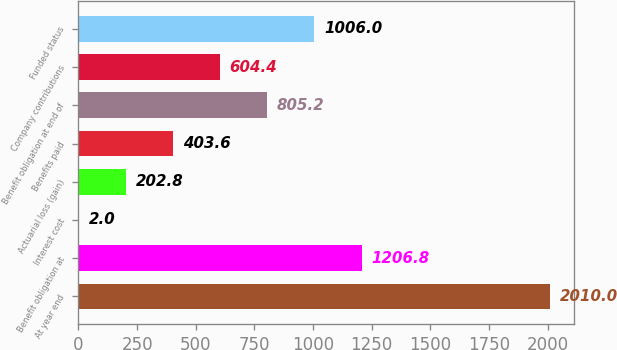Convert chart to OTSL. <chart><loc_0><loc_0><loc_500><loc_500><bar_chart><fcel>At year end<fcel>Benefit obligation at<fcel>Interest cost<fcel>Actuarial loss (gain)<fcel>Benefits paid<fcel>Benefit obligation at end of<fcel>Company contributions<fcel>Funded status<nl><fcel>2010<fcel>1206.8<fcel>2<fcel>202.8<fcel>403.6<fcel>805.2<fcel>604.4<fcel>1006<nl></chart> 